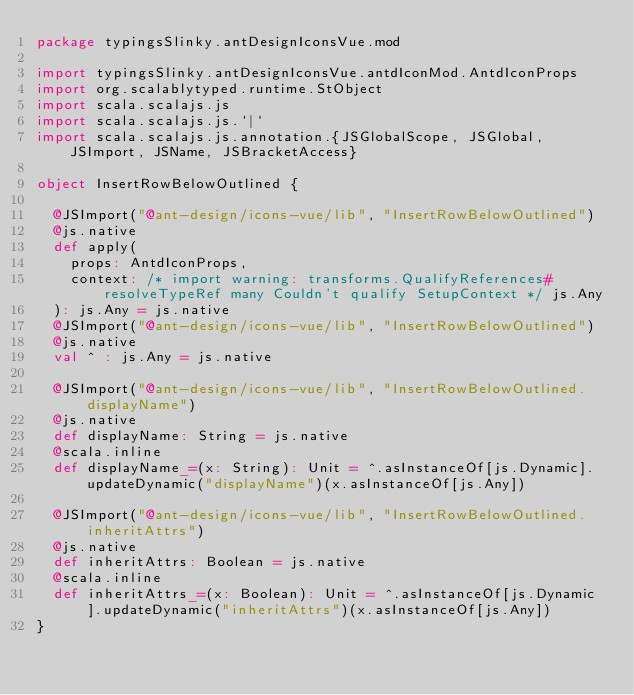<code> <loc_0><loc_0><loc_500><loc_500><_Scala_>package typingsSlinky.antDesignIconsVue.mod

import typingsSlinky.antDesignIconsVue.antdIconMod.AntdIconProps
import org.scalablytyped.runtime.StObject
import scala.scalajs.js
import scala.scalajs.js.`|`
import scala.scalajs.js.annotation.{JSGlobalScope, JSGlobal, JSImport, JSName, JSBracketAccess}

object InsertRowBelowOutlined {
  
  @JSImport("@ant-design/icons-vue/lib", "InsertRowBelowOutlined")
  @js.native
  def apply(
    props: AntdIconProps,
    context: /* import warning: transforms.QualifyReferences#resolveTypeRef many Couldn't qualify SetupContext */ js.Any
  ): js.Any = js.native
  @JSImport("@ant-design/icons-vue/lib", "InsertRowBelowOutlined")
  @js.native
  val ^ : js.Any = js.native
  
  @JSImport("@ant-design/icons-vue/lib", "InsertRowBelowOutlined.displayName")
  @js.native
  def displayName: String = js.native
  @scala.inline
  def displayName_=(x: String): Unit = ^.asInstanceOf[js.Dynamic].updateDynamic("displayName")(x.asInstanceOf[js.Any])
  
  @JSImport("@ant-design/icons-vue/lib", "InsertRowBelowOutlined.inheritAttrs")
  @js.native
  def inheritAttrs: Boolean = js.native
  @scala.inline
  def inheritAttrs_=(x: Boolean): Unit = ^.asInstanceOf[js.Dynamic].updateDynamic("inheritAttrs")(x.asInstanceOf[js.Any])
}
</code> 